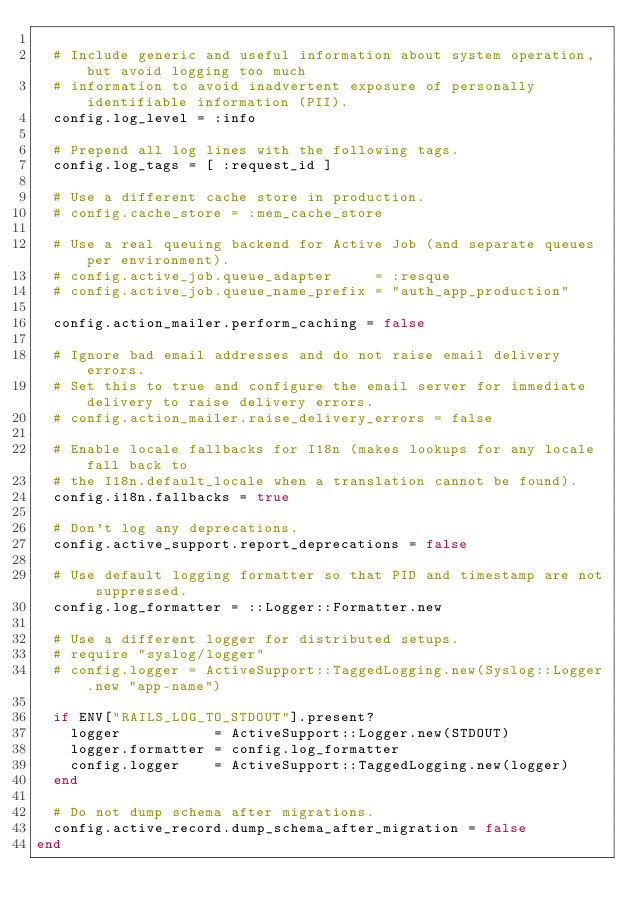<code> <loc_0><loc_0><loc_500><loc_500><_Ruby_>
  # Include generic and useful information about system operation, but avoid logging too much
  # information to avoid inadvertent exposure of personally identifiable information (PII).
  config.log_level = :info

  # Prepend all log lines with the following tags.
  config.log_tags = [ :request_id ]

  # Use a different cache store in production.
  # config.cache_store = :mem_cache_store

  # Use a real queuing backend for Active Job (and separate queues per environment).
  # config.active_job.queue_adapter     = :resque
  # config.active_job.queue_name_prefix = "auth_app_production"

  config.action_mailer.perform_caching = false

  # Ignore bad email addresses and do not raise email delivery errors.
  # Set this to true and configure the email server for immediate delivery to raise delivery errors.
  # config.action_mailer.raise_delivery_errors = false

  # Enable locale fallbacks for I18n (makes lookups for any locale fall back to
  # the I18n.default_locale when a translation cannot be found).
  config.i18n.fallbacks = true

  # Don't log any deprecations.
  config.active_support.report_deprecations = false

  # Use default logging formatter so that PID and timestamp are not suppressed.
  config.log_formatter = ::Logger::Formatter.new

  # Use a different logger for distributed setups.
  # require "syslog/logger"
  # config.logger = ActiveSupport::TaggedLogging.new(Syslog::Logger.new "app-name")

  if ENV["RAILS_LOG_TO_STDOUT"].present?
    logger           = ActiveSupport::Logger.new(STDOUT)
    logger.formatter = config.log_formatter
    config.logger    = ActiveSupport::TaggedLogging.new(logger)
  end

  # Do not dump schema after migrations.
  config.active_record.dump_schema_after_migration = false
end
</code> 